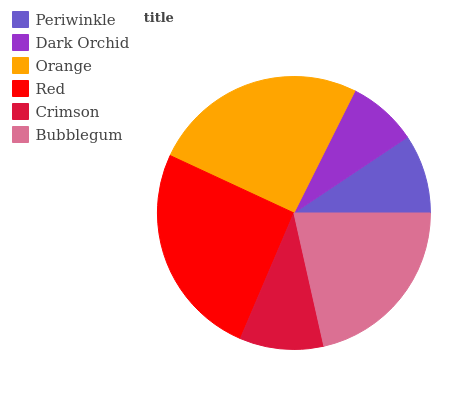Is Dark Orchid the minimum?
Answer yes or no. Yes. Is Red the maximum?
Answer yes or no. Yes. Is Orange the minimum?
Answer yes or no. No. Is Orange the maximum?
Answer yes or no. No. Is Orange greater than Dark Orchid?
Answer yes or no. Yes. Is Dark Orchid less than Orange?
Answer yes or no. Yes. Is Dark Orchid greater than Orange?
Answer yes or no. No. Is Orange less than Dark Orchid?
Answer yes or no. No. Is Bubblegum the high median?
Answer yes or no. Yes. Is Crimson the low median?
Answer yes or no. Yes. Is Periwinkle the high median?
Answer yes or no. No. Is Orange the low median?
Answer yes or no. No. 